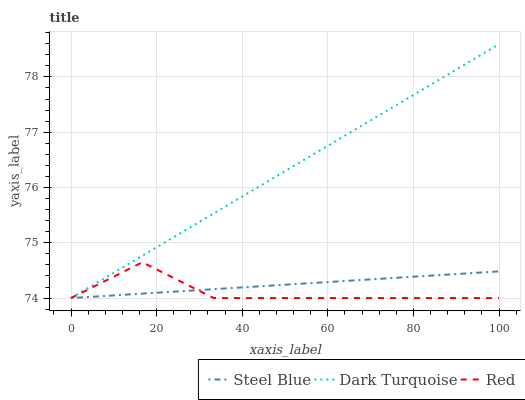Does Red have the minimum area under the curve?
Answer yes or no. Yes. Does Dark Turquoise have the maximum area under the curve?
Answer yes or no. Yes. Does Steel Blue have the minimum area under the curve?
Answer yes or no. No. Does Steel Blue have the maximum area under the curve?
Answer yes or no. No. Is Steel Blue the smoothest?
Answer yes or no. Yes. Is Red the roughest?
Answer yes or no. Yes. Is Red the smoothest?
Answer yes or no. No. Is Steel Blue the roughest?
Answer yes or no. No. Does Dark Turquoise have the highest value?
Answer yes or no. Yes. Does Red have the highest value?
Answer yes or no. No. Does Steel Blue intersect Dark Turquoise?
Answer yes or no. Yes. Is Steel Blue less than Dark Turquoise?
Answer yes or no. No. Is Steel Blue greater than Dark Turquoise?
Answer yes or no. No. 